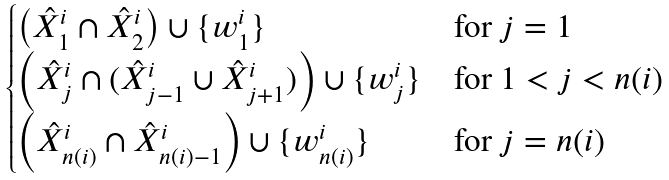<formula> <loc_0><loc_0><loc_500><loc_500>\begin{cases} \left ( \hat { X } _ { 1 } ^ { i } \cap \hat { X } _ { 2 } ^ { i } \right ) \cup \{ w _ { 1 } ^ { i } \} & \text {for } j = 1 \\ \left ( \hat { X } _ { j } ^ { i } \cap ( \hat { X } _ { j - 1 } ^ { i } \cup \hat { X } _ { j + 1 } ^ { i } ) \right ) \cup \{ w _ { j } ^ { i } \} & \text {for } 1 < j < n ( i ) \\ \left ( \hat { X } _ { n ( i ) } ^ { i } \cap \hat { X } _ { n ( i ) - 1 } ^ { i } \right ) \cup \{ w _ { n ( i ) } ^ { i } \} & \text {for } j = n ( i ) \end{cases}</formula> 